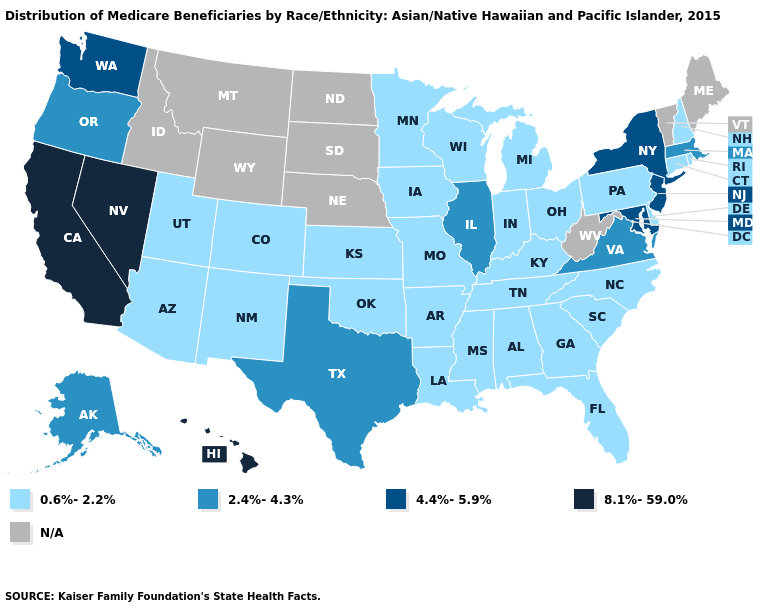Which states have the lowest value in the West?
Give a very brief answer. Arizona, Colorado, New Mexico, Utah. How many symbols are there in the legend?
Be succinct. 5. Name the states that have a value in the range 8.1%-59.0%?
Give a very brief answer. California, Hawaii, Nevada. What is the highest value in the West ?
Write a very short answer. 8.1%-59.0%. What is the value of California?
Short answer required. 8.1%-59.0%. What is the highest value in the USA?
Give a very brief answer. 8.1%-59.0%. Name the states that have a value in the range 0.6%-2.2%?
Be succinct. Alabama, Arizona, Arkansas, Colorado, Connecticut, Delaware, Florida, Georgia, Indiana, Iowa, Kansas, Kentucky, Louisiana, Michigan, Minnesota, Mississippi, Missouri, New Hampshire, New Mexico, North Carolina, Ohio, Oklahoma, Pennsylvania, Rhode Island, South Carolina, Tennessee, Utah, Wisconsin. Which states have the highest value in the USA?
Give a very brief answer. California, Hawaii, Nevada. Among the states that border Wyoming , which have the highest value?
Short answer required. Colorado, Utah. Name the states that have a value in the range 2.4%-4.3%?
Answer briefly. Alaska, Illinois, Massachusetts, Oregon, Texas, Virginia. What is the value of Maryland?
Keep it brief. 4.4%-5.9%. 